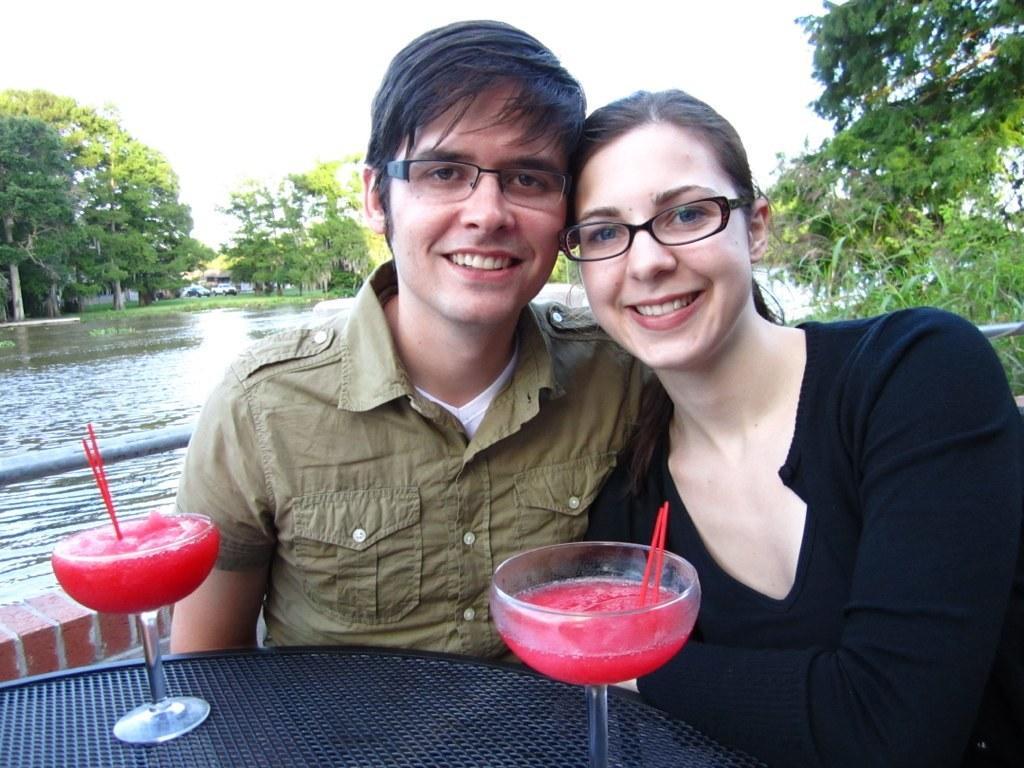Describe this image in one or two sentences. In the foreground of this image, there is a man and a woman sitting in front of a table on which there are two glasses. In the background, there is water, trees and the sky. 